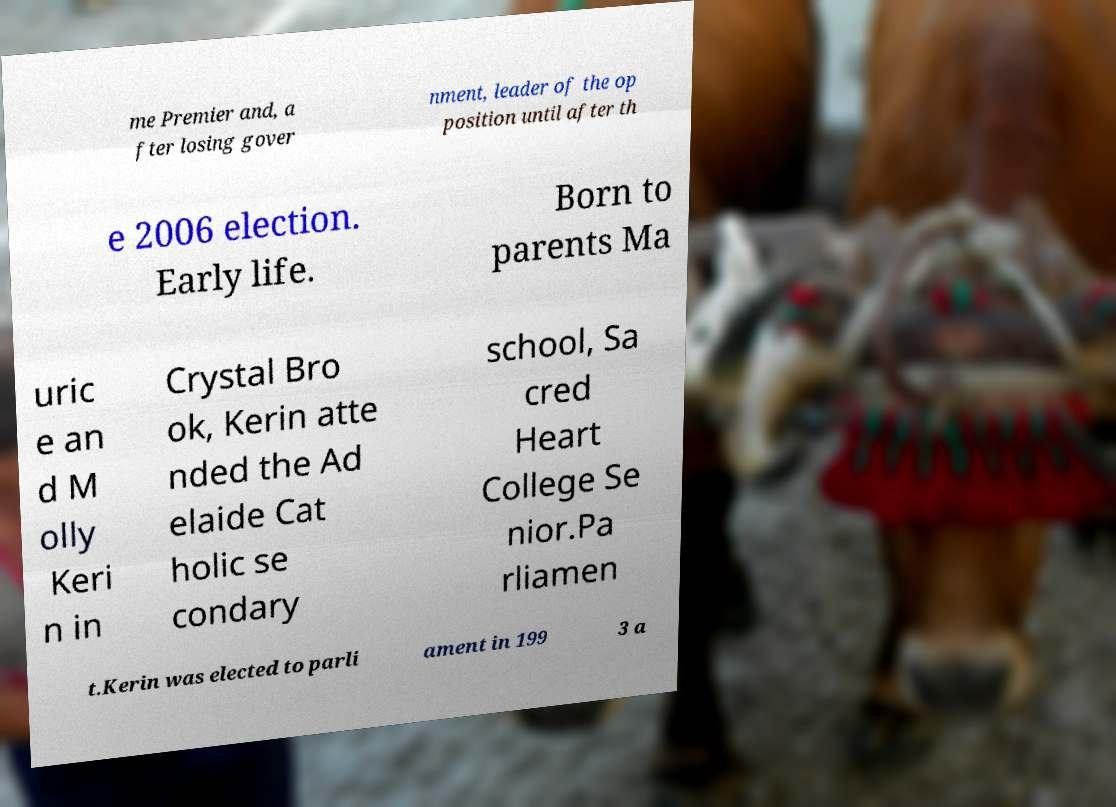Please identify and transcribe the text found in this image. me Premier and, a fter losing gover nment, leader of the op position until after th e 2006 election. Early life. Born to parents Ma uric e an d M olly Keri n in Crystal Bro ok, Kerin atte nded the Ad elaide Cat holic se condary school, Sa cred Heart College Se nior.Pa rliamen t.Kerin was elected to parli ament in 199 3 a 